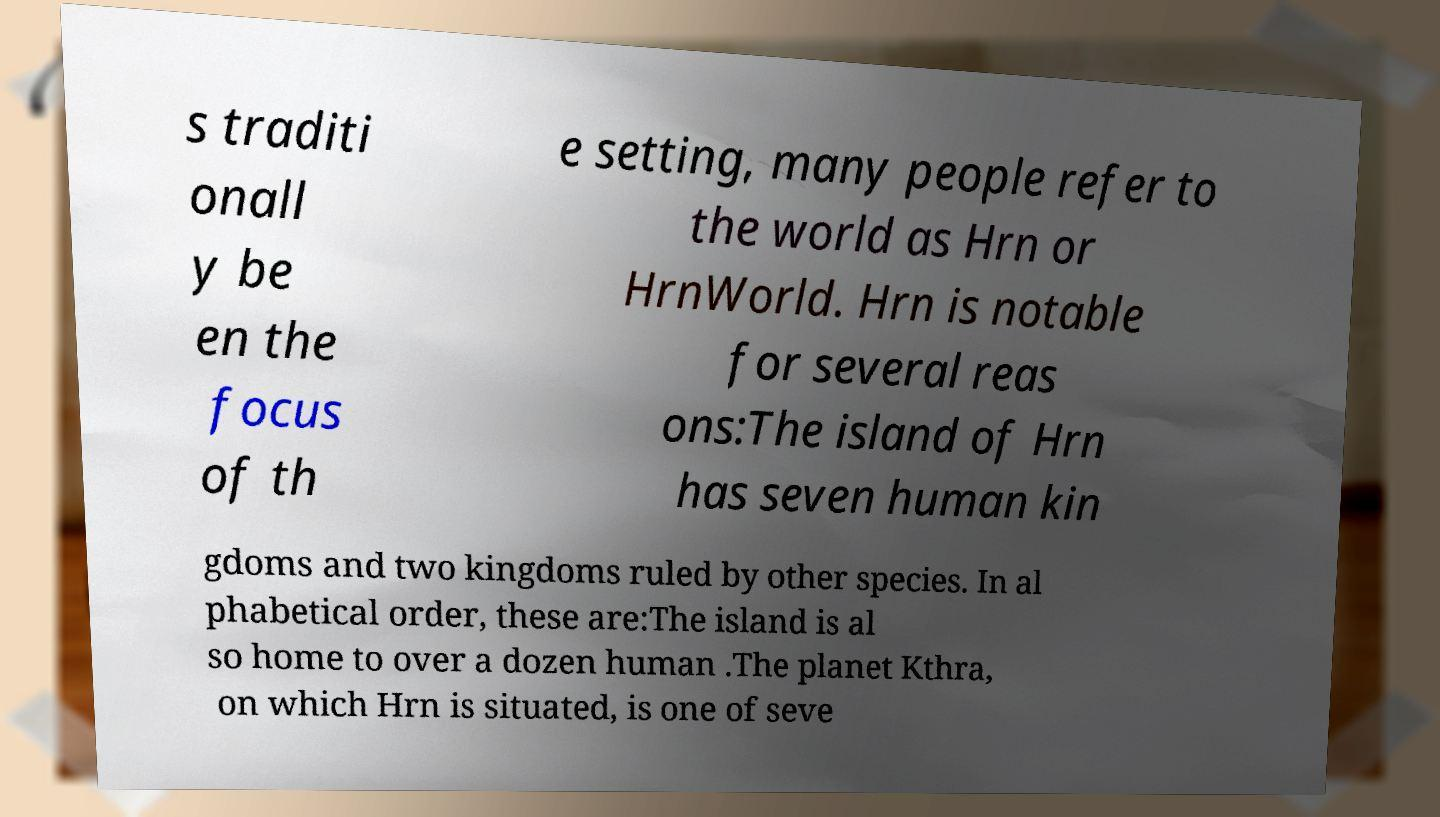There's text embedded in this image that I need extracted. Can you transcribe it verbatim? s traditi onall y be en the focus of th e setting, many people refer to the world as Hrn or HrnWorld. Hrn is notable for several reas ons:The island of Hrn has seven human kin gdoms and two kingdoms ruled by other species. In al phabetical order, these are:The island is al so home to over a dozen human .The planet Kthra, on which Hrn is situated, is one of seve 